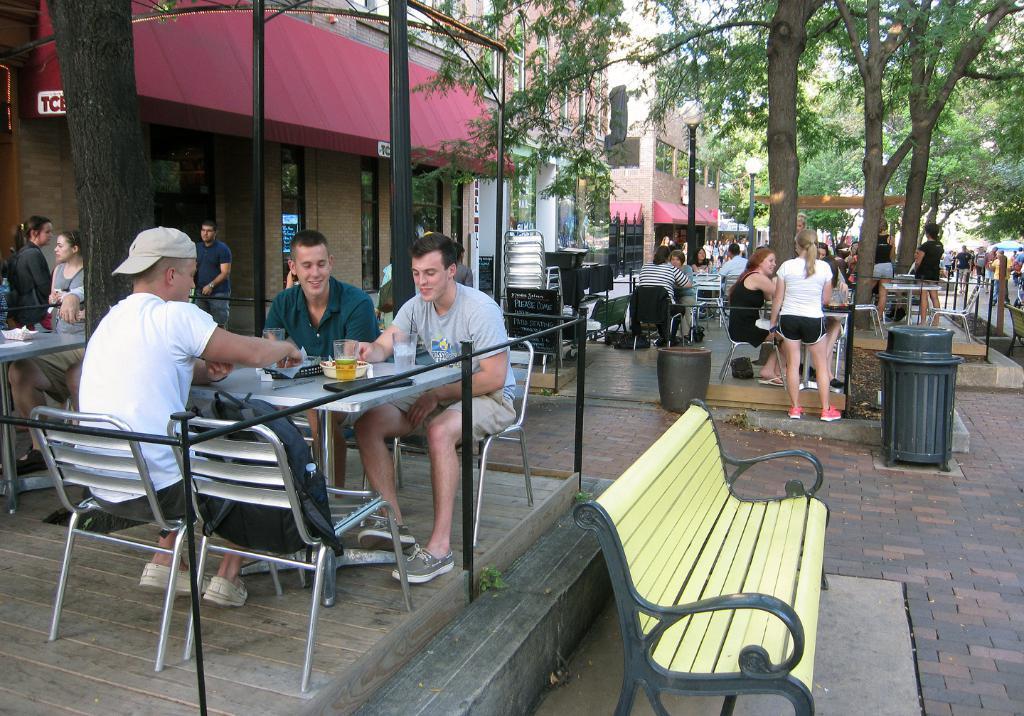Please provide a concise description of this image. Here we can see that a group of people sitting on the chair, and in front here is the table and cups and some other objects on it, and here is the table on the floor, and here is the tree, and here is the building. 